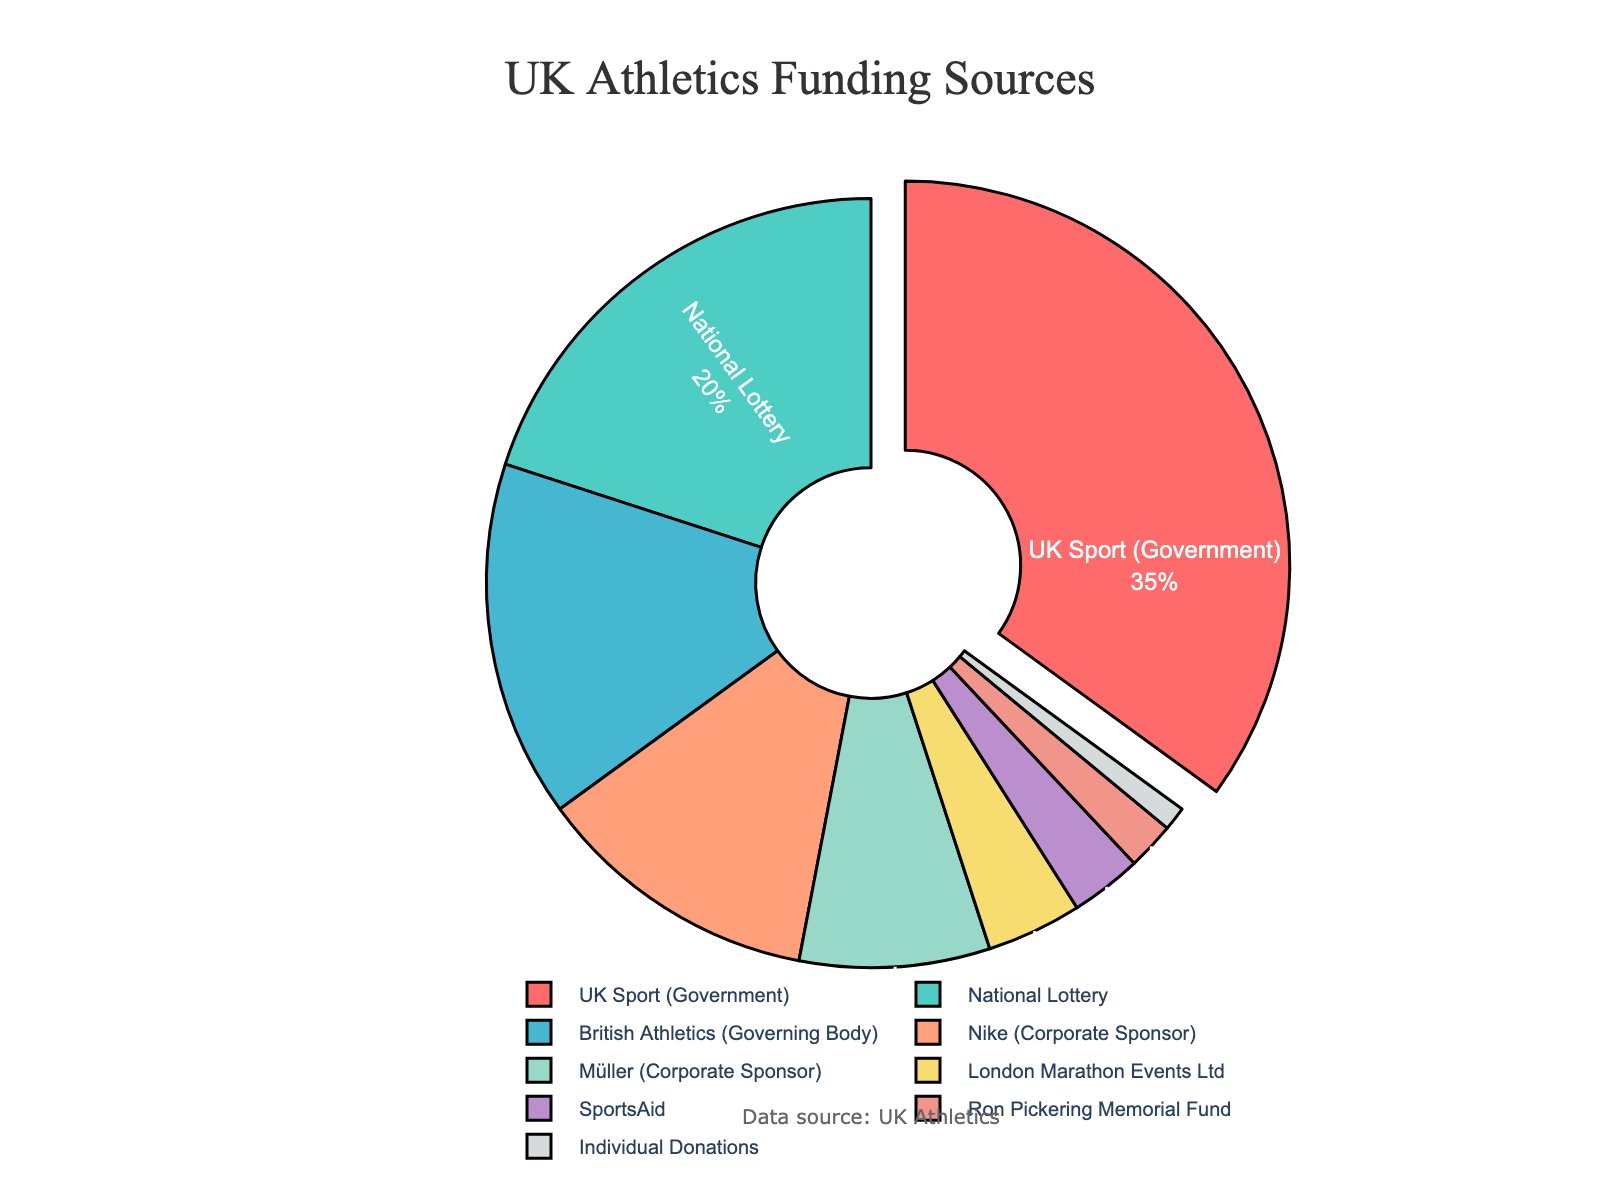What percentage of funding comes from government-related sources? First, identify all government-related sources. The figure indicates "UK Sport (Government)" and "National Lottery". Next, add their percentages: 35% (UK Sport) + 20% (National Lottery) = 55%.
Answer: 55% Which funding source provides the highest percentage of funds? Look for the largest segment in the pie chart. The "UK Sport (Government)" section is the largest, representing 35%.
Answer: UK Sport (Government) Is the percentage contributed by Nike greater than that contributed by Müller? Locate the segments for "Nike (Corporate Sponsor)" and "Müller (Corporate Sponsor)". Nike provides 12%, and Müller provides 8%. Compare the two percentages: 12% > 8%.
Answer: Yes What is the combined funding percentage of corporate sponsors (Nike and Müller)? Identify and add the percentages for the corporate sponsors: Nike provides 12% and Müller provides 8%. The combined percentage is 12% + 8% = 20%.
Answer: 20% Which funding source contributes the least? Locate the smallest segment in the pie chart. The "Individual Donations" segment is the smallest, representing 1%.
Answer: Individual Donations How much greater is the contribution percentage from UK Sport compared to British Athletics? Identify the percentages for both sources: UK Sport (Government) is 35%, and British Athletics is 15%. Subtract the percentage for British Athletics from UK Sport: 35% - 15% = 20%.
Answer: 20% What is the average funding percentage of London Marathon Events Ltd, SportsAid, and Ron Pickering Memorial Fund? Identify the percentages: London Marathon Events Ltd (4%), SportsAid (3%), and Ron Pickering Memorial Fund (2%). Add these percentages: 4% + 3% + 2% = 9%. Then, divide by the number of sources (3): 9% / 3 = 3%.
Answer: 3% Does British Athletics contribute more than Nike and Müller combined? Determine the contribution percentages: British Athletics (15%), Nike (12%), and Müller (8%). Combine Nike and Müller: 12% + 8% = 20%. Compare the totals: 15% (British Athletics) < 20% (Nike and Müller).
Answer: No What is the total funding percentage from non-governmental sources? Subtract the total government-related funding percentage (55%) from 100%: 100% - 55% = 45%.
Answer: 45% What are the primary colors used for the pie chart slices for UK Sport and National Lottery? The visually prominent colors in the pie chart segments for UK Sport and National Lottery are red and green, respectively.
Answer: Red, Green 